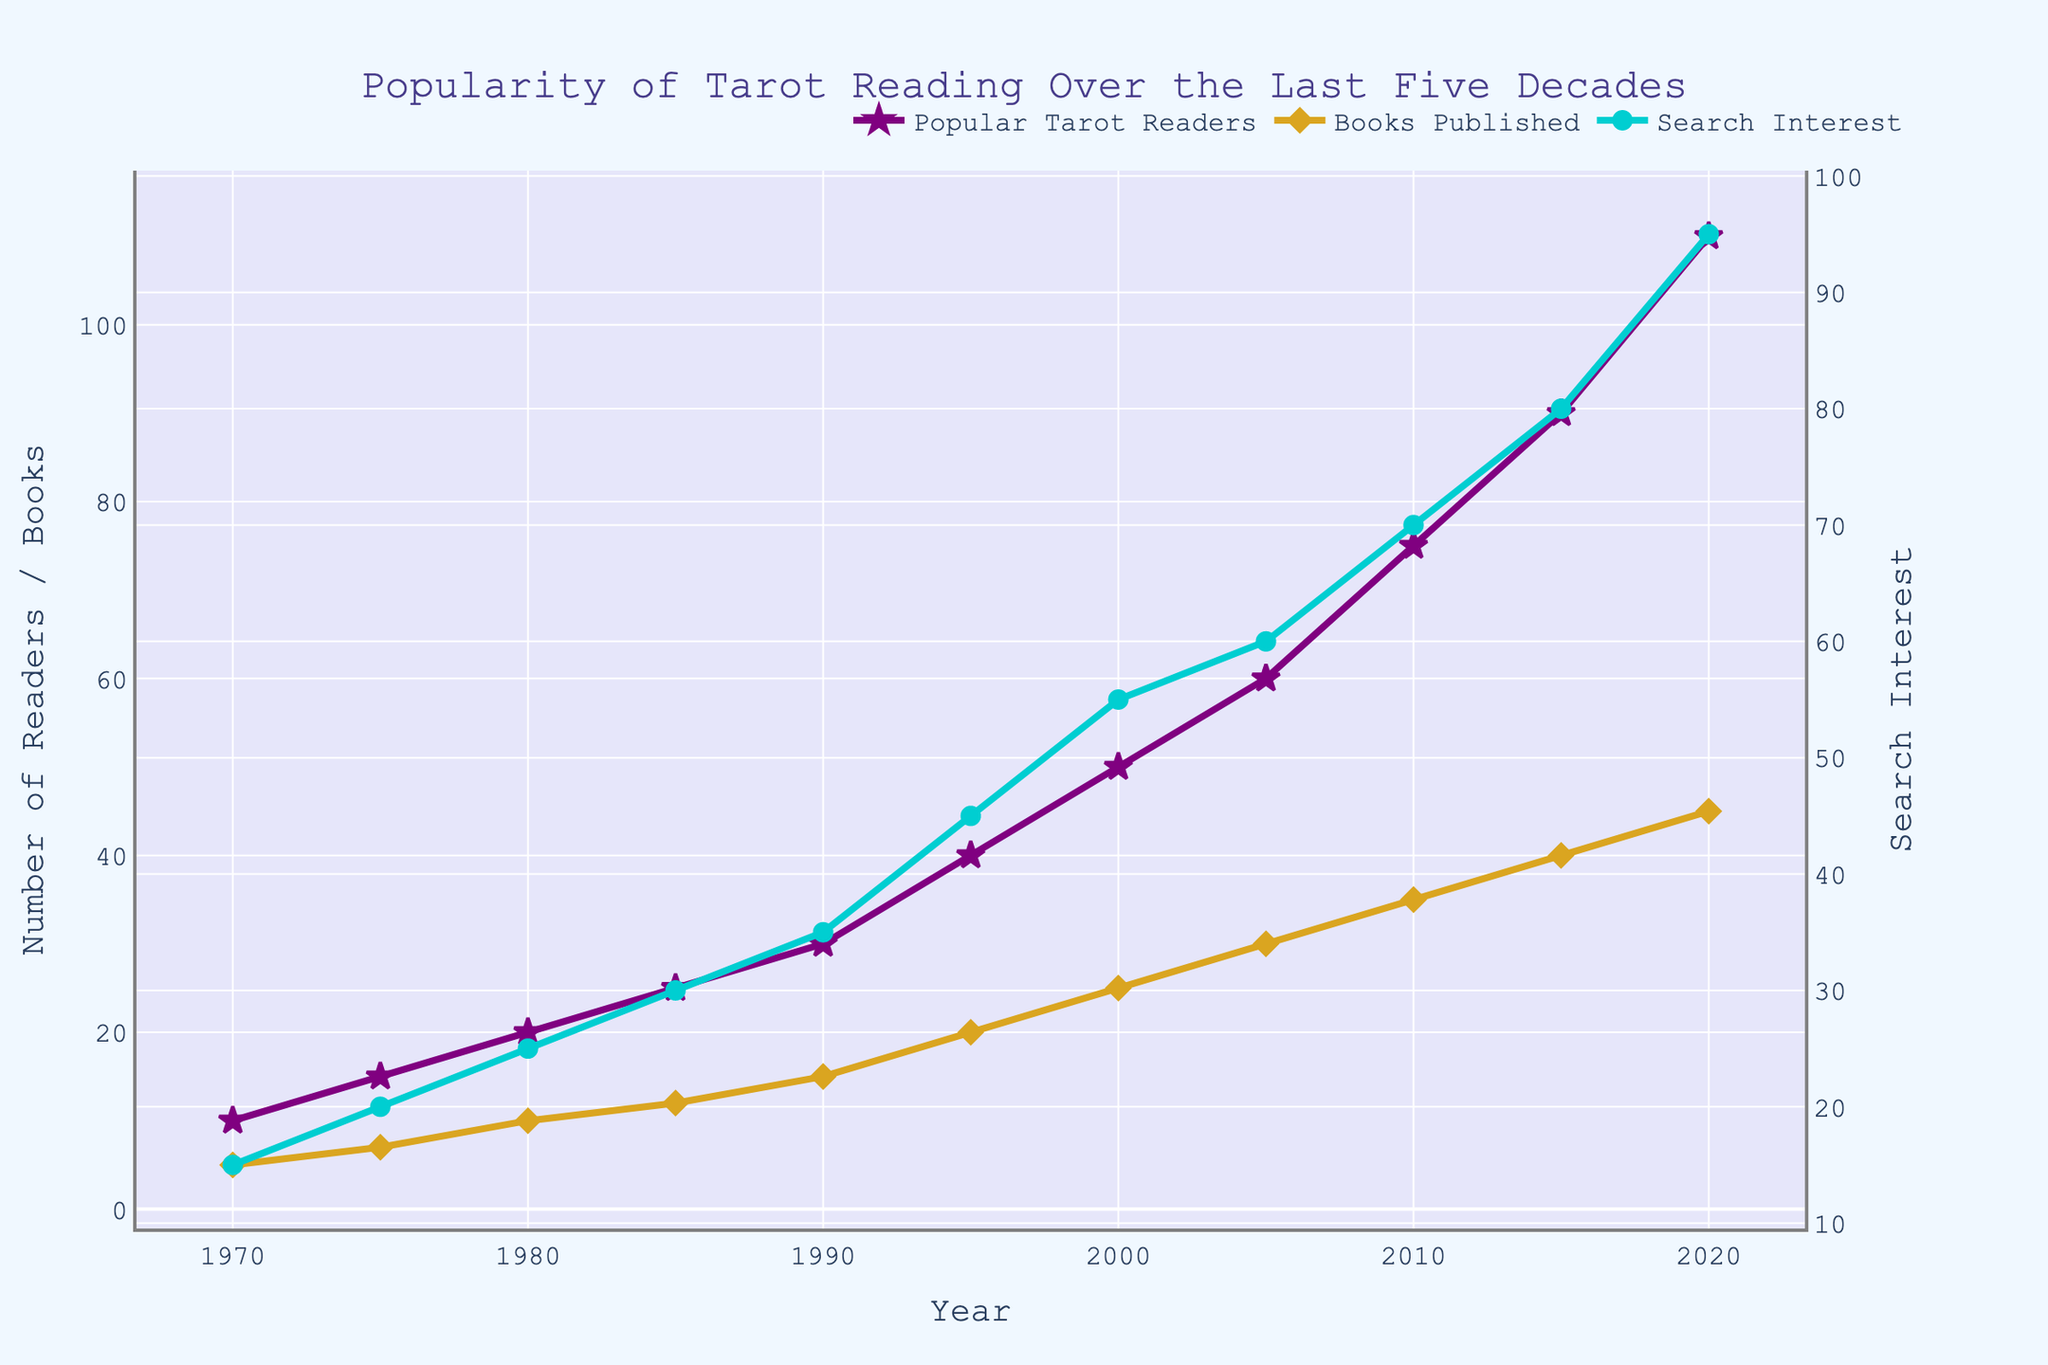What is the title of the figure? The title is located at the top of the figure, it reads "Popularity of Tarot Reading Over the Last Five Decades".
Answer: Popularity of Tarot Reading Over the Last Five Decades How many data points are there for "Books Published"? Count the number of markers for "Books Published" which is represented by yellow diamonds in the figure. There are data points from 1970 to 2020, in increments of 5 years.
Answer: 11 Which metric shows the highest value in the year 2020? Compare the values of "Popular Tarot Readers", "Books Published", and "Search Interest" at the year 2020. The highest value is for "Search Interest", which is 95.
Answer: Search Interest How does the number of "Popular Tarot Readers" change from 1970 to 2020? Observe the trend line for "Popular Tarot Readers" which increases gradually from 10 in 1970 to 110 in 2020.
Answer: Increases Which year experienced the highest increase in the number of "Search Interest"? Look at the difference between the "Search Interest" values across consecutive years. The biggest increase is from 2015 (80) to 2020 (95) which is an increase of 15.
Answer: 2015-2020 Compare the values of "Books Published" and "Popular Tarot Readers" in 1990. Which one is higher? Observe the plotted markers for 1990; "Books Published" is 15, while "Popular Tarot Readers" is 30.
Answer: Popular Tarot Readers What is the difference in the number of "Popular Tarot Readers" between 1980 and 1995? Subtract the 1980 value of "Popular Tarot Readers" (20) from the 1995 value (40). The difference is 20.
Answer: 20 What trend do you notice for "Books Published" from 1970 to 2020? The line for "Books Published" shows a steady increasing trend from 5 in 1970 to 45 in 2020.
Answer: Increases steadily How does "Search Interest" correlate with "Popular Tarot Readers" over the decades? Examine if both lines exhibit similar trends; both lines increase over time, suggesting a positive correlation.
Answer: Positive correlation What is the average value of "Search Interest" across the observed decades? Add all the "Search Interest" values and divide by the number of data points (11). (15 + 20 + 25 + 30 + 35 + 45 + 55 + 60 + 70 + 80 + 95) / 11 = 47.27
Answer: 47.27 